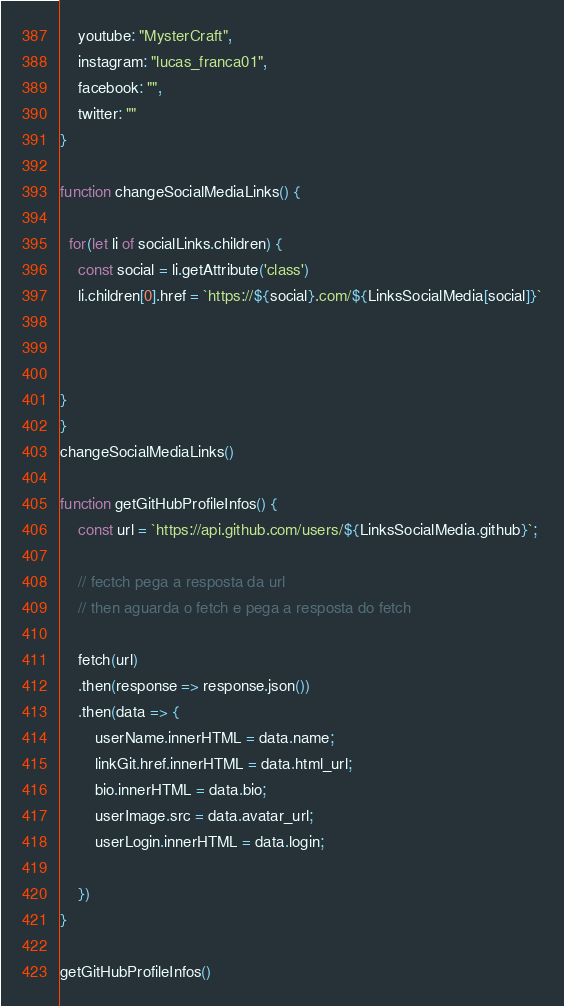<code> <loc_0><loc_0><loc_500><loc_500><_JavaScript_>    youtube: "MysterCraft",
    instagram: "lucas_franca01",
    facebook: "",
    twitter: ""
}

function changeSocialMediaLinks() {

  for(let li of socialLinks.children) {
    const social = li.getAttribute('class')
    li.children[0].href = `https://${social}.com/${LinksSocialMedia[social]}`
  


}
}
changeSocialMediaLinks()

function getGitHubProfileInfos() {
    const url = `https://api.github.com/users/${LinksSocialMedia.github}`;

    // fectch pega a resposta da url
    // then aguarda o fetch e pega a resposta do fetch

    fetch(url)
    .then(response => response.json())
    .then(data => {
        userName.innerHTML = data.name;
        linkGit.href.innerHTML = data.html_url;
        bio.innerHTML = data.bio;
        userImage.src = data.avatar_url;
        userLogin.innerHTML = data.login;

    })
}

getGitHubProfileInfos()</code> 